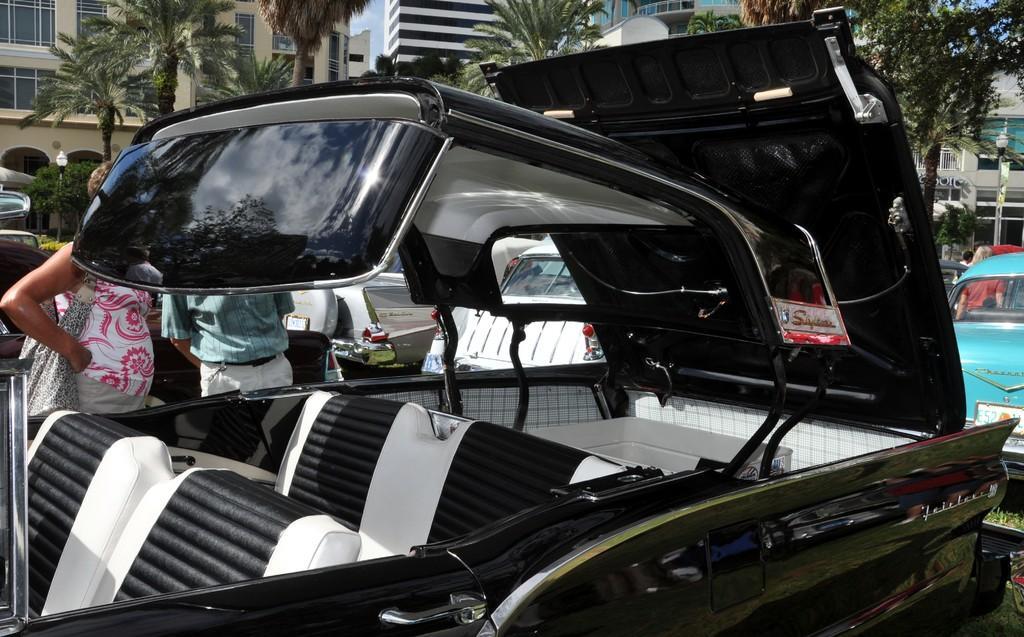Describe this image in one or two sentences. In this image I can see a car which is black and white in color. In the background I can see few persons standing, few other vehicles, few trees, few poles, few buildings and the sky. 